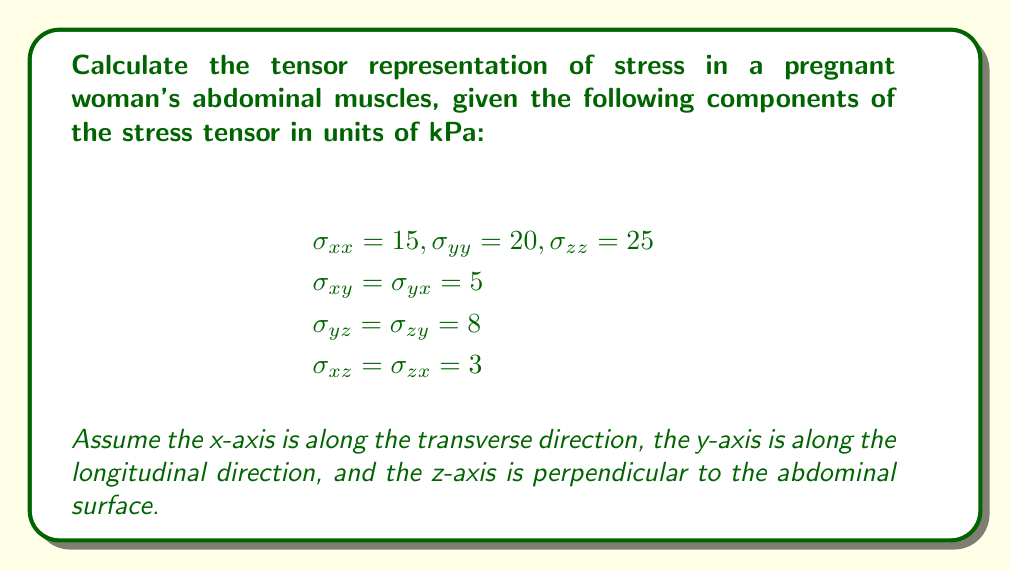Show me your answer to this math problem. To calculate the tensor representation of stress in the pregnant woman's abdominal muscles, we need to construct the stress tensor using the given components. The stress tensor is a second-order tensor represented by a 3x3 matrix.

Step 1: Identify the components of the stress tensor.
- Normal stresses: $\sigma_{xx}$, $\sigma_{yy}$, $\sigma_{zz}$
- Shear stresses: $\sigma_{xy} = \sigma_{yx}$, $\sigma_{yz} = \sigma_{zy}$, $\sigma_{xz} = \sigma_{zx}$

Step 2: Construct the stress tensor matrix.
The stress tensor $\boldsymbol{\sigma}$ is given by:

$$\boldsymbol{\sigma} = \begin{bmatrix}
\sigma_{xx} & \sigma_{xy} & \sigma_{xz} \\
\sigma_{yx} & \sigma_{yy} & \sigma_{yz} \\
\sigma_{zx} & \sigma_{zy} & \sigma_{zz}
\end{bmatrix}$$

Step 3: Substitute the given values into the stress tensor matrix.

$$\boldsymbol{\sigma} = \begin{bmatrix}
15 & 5 & 3 \\
5 & 20 & 8 \\
3 & 8 & 25
\end{bmatrix} \text{ kPa}$$

This 3x3 matrix represents the tensor representation of stress in the pregnant woman's abdominal muscles, taking into account both normal and shear stresses in all directions.
Answer: $$\boldsymbol{\sigma} = \begin{bmatrix}
15 & 5 & 3 \\
5 & 20 & 8 \\
3 & 8 & 25
\end{bmatrix} \text{ kPa}$$ 